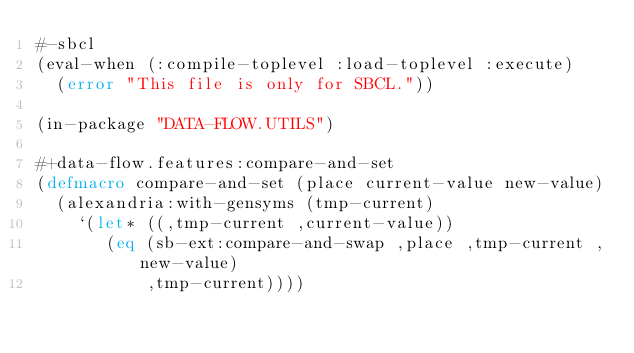Convert code to text. <code><loc_0><loc_0><loc_500><loc_500><_Lisp_>#-sbcl
(eval-when (:compile-toplevel :load-toplevel :execute)
  (error "This file is only for SBCL."))

(in-package "DATA-FLOW.UTILS")

#+data-flow.features:compare-and-set
(defmacro compare-and-set (place current-value new-value)
  (alexandria:with-gensyms (tmp-current)
    `(let* ((,tmp-current ,current-value))
       (eq (sb-ext:compare-and-swap ,place ,tmp-current ,new-value)
           ,tmp-current))))
</code> 